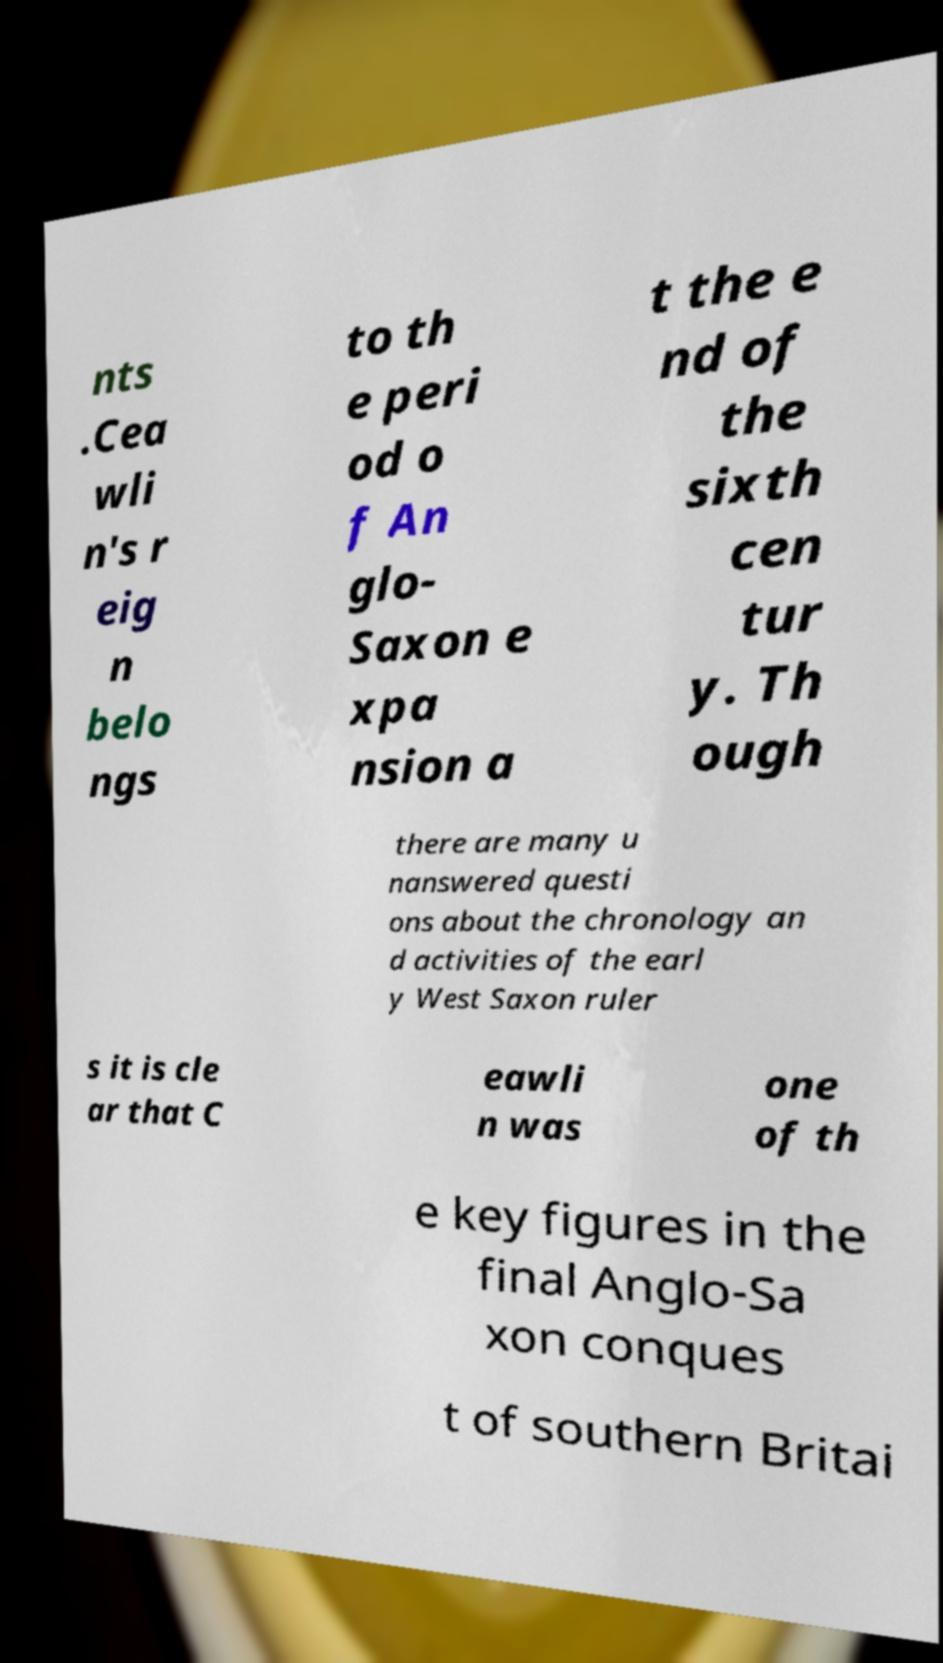There's text embedded in this image that I need extracted. Can you transcribe it verbatim? nts .Cea wli n's r eig n belo ngs to th e peri od o f An glo- Saxon e xpa nsion a t the e nd of the sixth cen tur y. Th ough there are many u nanswered questi ons about the chronology an d activities of the earl y West Saxon ruler s it is cle ar that C eawli n was one of th e key figures in the final Anglo-Sa xon conques t of southern Britai 